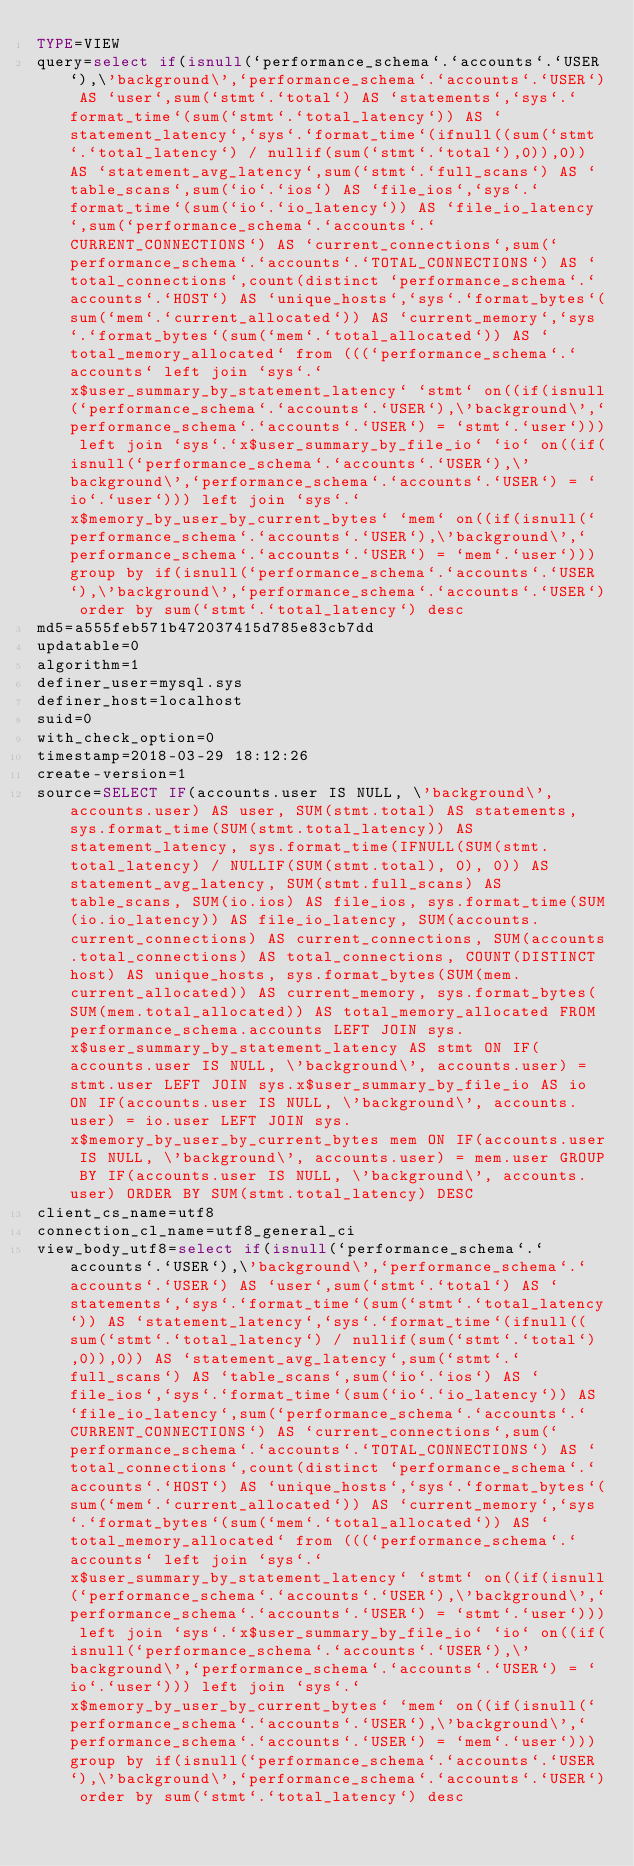<code> <loc_0><loc_0><loc_500><loc_500><_VisualBasic_>TYPE=VIEW
query=select if(isnull(`performance_schema`.`accounts`.`USER`),\'background\',`performance_schema`.`accounts`.`USER`) AS `user`,sum(`stmt`.`total`) AS `statements`,`sys`.`format_time`(sum(`stmt`.`total_latency`)) AS `statement_latency`,`sys`.`format_time`(ifnull((sum(`stmt`.`total_latency`) / nullif(sum(`stmt`.`total`),0)),0)) AS `statement_avg_latency`,sum(`stmt`.`full_scans`) AS `table_scans`,sum(`io`.`ios`) AS `file_ios`,`sys`.`format_time`(sum(`io`.`io_latency`)) AS `file_io_latency`,sum(`performance_schema`.`accounts`.`CURRENT_CONNECTIONS`) AS `current_connections`,sum(`performance_schema`.`accounts`.`TOTAL_CONNECTIONS`) AS `total_connections`,count(distinct `performance_schema`.`accounts`.`HOST`) AS `unique_hosts`,`sys`.`format_bytes`(sum(`mem`.`current_allocated`)) AS `current_memory`,`sys`.`format_bytes`(sum(`mem`.`total_allocated`)) AS `total_memory_allocated` from (((`performance_schema`.`accounts` left join `sys`.`x$user_summary_by_statement_latency` `stmt` on((if(isnull(`performance_schema`.`accounts`.`USER`),\'background\',`performance_schema`.`accounts`.`USER`) = `stmt`.`user`))) left join `sys`.`x$user_summary_by_file_io` `io` on((if(isnull(`performance_schema`.`accounts`.`USER`),\'background\',`performance_schema`.`accounts`.`USER`) = `io`.`user`))) left join `sys`.`x$memory_by_user_by_current_bytes` `mem` on((if(isnull(`performance_schema`.`accounts`.`USER`),\'background\',`performance_schema`.`accounts`.`USER`) = `mem`.`user`))) group by if(isnull(`performance_schema`.`accounts`.`USER`),\'background\',`performance_schema`.`accounts`.`USER`) order by sum(`stmt`.`total_latency`) desc
md5=a555feb571b472037415d785e83cb7dd
updatable=0
algorithm=1
definer_user=mysql.sys
definer_host=localhost
suid=0
with_check_option=0
timestamp=2018-03-29 18:12:26
create-version=1
source=SELECT IF(accounts.user IS NULL, \'background\', accounts.user) AS user, SUM(stmt.total) AS statements, sys.format_time(SUM(stmt.total_latency)) AS statement_latency, sys.format_time(IFNULL(SUM(stmt.total_latency) / NULLIF(SUM(stmt.total), 0), 0)) AS statement_avg_latency, SUM(stmt.full_scans) AS table_scans, SUM(io.ios) AS file_ios, sys.format_time(SUM(io.io_latency)) AS file_io_latency, SUM(accounts.current_connections) AS current_connections, SUM(accounts.total_connections) AS total_connections, COUNT(DISTINCT host) AS unique_hosts, sys.format_bytes(SUM(mem.current_allocated)) AS current_memory, sys.format_bytes(SUM(mem.total_allocated)) AS total_memory_allocated FROM performance_schema.accounts LEFT JOIN sys.x$user_summary_by_statement_latency AS stmt ON IF(accounts.user IS NULL, \'background\', accounts.user) = stmt.user LEFT JOIN sys.x$user_summary_by_file_io AS io ON IF(accounts.user IS NULL, \'background\', accounts.user) = io.user LEFT JOIN sys.x$memory_by_user_by_current_bytes mem ON IF(accounts.user IS NULL, \'background\', accounts.user) = mem.user GROUP BY IF(accounts.user IS NULL, \'background\', accounts.user) ORDER BY SUM(stmt.total_latency) DESC
client_cs_name=utf8
connection_cl_name=utf8_general_ci
view_body_utf8=select if(isnull(`performance_schema`.`accounts`.`USER`),\'background\',`performance_schema`.`accounts`.`USER`) AS `user`,sum(`stmt`.`total`) AS `statements`,`sys`.`format_time`(sum(`stmt`.`total_latency`)) AS `statement_latency`,`sys`.`format_time`(ifnull((sum(`stmt`.`total_latency`) / nullif(sum(`stmt`.`total`),0)),0)) AS `statement_avg_latency`,sum(`stmt`.`full_scans`) AS `table_scans`,sum(`io`.`ios`) AS `file_ios`,`sys`.`format_time`(sum(`io`.`io_latency`)) AS `file_io_latency`,sum(`performance_schema`.`accounts`.`CURRENT_CONNECTIONS`) AS `current_connections`,sum(`performance_schema`.`accounts`.`TOTAL_CONNECTIONS`) AS `total_connections`,count(distinct `performance_schema`.`accounts`.`HOST`) AS `unique_hosts`,`sys`.`format_bytes`(sum(`mem`.`current_allocated`)) AS `current_memory`,`sys`.`format_bytes`(sum(`mem`.`total_allocated`)) AS `total_memory_allocated` from (((`performance_schema`.`accounts` left join `sys`.`x$user_summary_by_statement_latency` `stmt` on((if(isnull(`performance_schema`.`accounts`.`USER`),\'background\',`performance_schema`.`accounts`.`USER`) = `stmt`.`user`))) left join `sys`.`x$user_summary_by_file_io` `io` on((if(isnull(`performance_schema`.`accounts`.`USER`),\'background\',`performance_schema`.`accounts`.`USER`) = `io`.`user`))) left join `sys`.`x$memory_by_user_by_current_bytes` `mem` on((if(isnull(`performance_schema`.`accounts`.`USER`),\'background\',`performance_schema`.`accounts`.`USER`) = `mem`.`user`))) group by if(isnull(`performance_schema`.`accounts`.`USER`),\'background\',`performance_schema`.`accounts`.`USER`) order by sum(`stmt`.`total_latency`) desc
</code> 